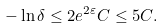Convert formula to latex. <formula><loc_0><loc_0><loc_500><loc_500>- \ln \delta \leq 2 e ^ { 2 \varepsilon } C \leq 5 C .</formula> 